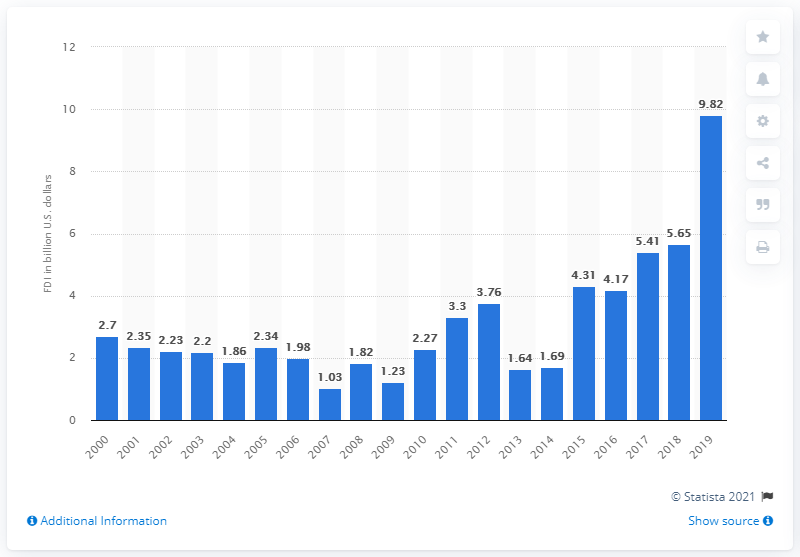Highlight a few significant elements in this photo. According to data from 2019, the amount of African foreign direct investments in the United States was 9.82. 